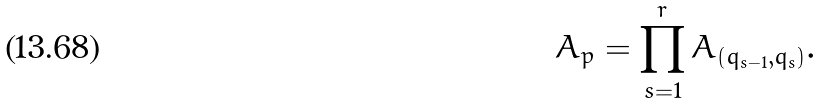Convert formula to latex. <formula><loc_0><loc_0><loc_500><loc_500>A _ { p } = \prod _ { s = 1 } ^ { r } A _ { ( q _ { s - 1 } , q _ { s } ) } .</formula> 